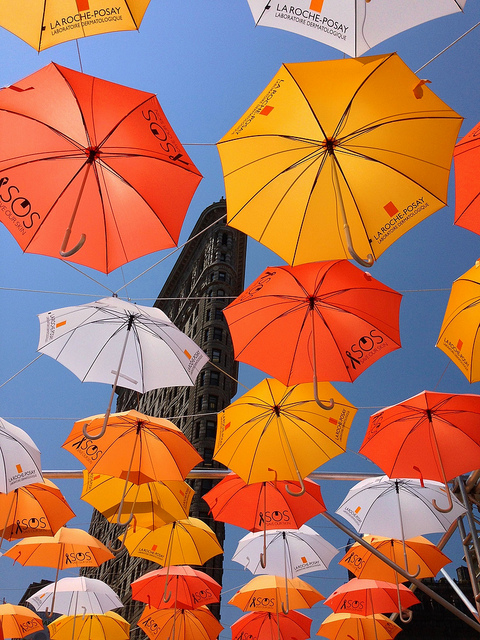Please transcribe the text in this image. LAROCHE- .POSAY LAROCHE.POSAY SOS LAROCHE.POSAY LAROCHE-POSAY SOS SOS SOS SOS SOS SOS LAROCHE-POSAY LAROCHE-POSAY 